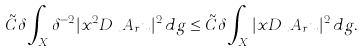Convert formula to latex. <formula><loc_0><loc_0><loc_500><loc_500>\tilde { C } \delta \int _ { X } \delta ^ { - 2 } | x ^ { 2 } D _ { x } A _ { r } u | ^ { 2 } \, d g \leq \tilde { C } \delta \int _ { X } | x D _ { x } A _ { r } u | ^ { 2 } \, d g .</formula> 